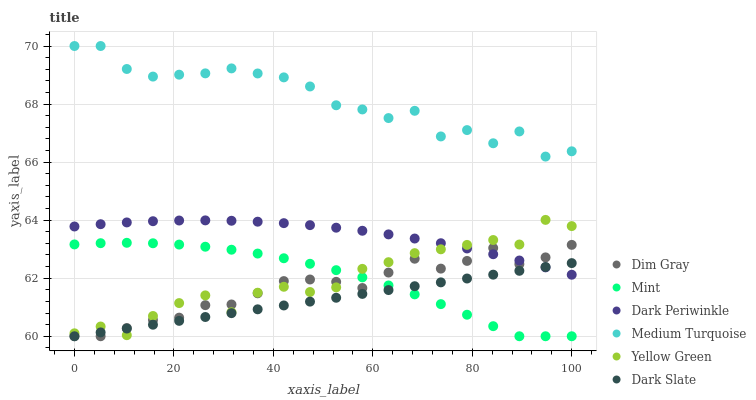Does Dark Slate have the minimum area under the curve?
Answer yes or no. Yes. Does Medium Turquoise have the maximum area under the curve?
Answer yes or no. Yes. Does Yellow Green have the minimum area under the curve?
Answer yes or no. No. Does Yellow Green have the maximum area under the curve?
Answer yes or no. No. Is Dark Slate the smoothest?
Answer yes or no. Yes. Is Medium Turquoise the roughest?
Answer yes or no. Yes. Is Yellow Green the smoothest?
Answer yes or no. No. Is Yellow Green the roughest?
Answer yes or no. No. Does Dim Gray have the lowest value?
Answer yes or no. Yes. Does Yellow Green have the lowest value?
Answer yes or no. No. Does Medium Turquoise have the highest value?
Answer yes or no. Yes. Does Yellow Green have the highest value?
Answer yes or no. No. Is Mint less than Medium Turquoise?
Answer yes or no. Yes. Is Medium Turquoise greater than Dark Slate?
Answer yes or no. Yes. Does Yellow Green intersect Dim Gray?
Answer yes or no. Yes. Is Yellow Green less than Dim Gray?
Answer yes or no. No. Is Yellow Green greater than Dim Gray?
Answer yes or no. No. Does Mint intersect Medium Turquoise?
Answer yes or no. No. 